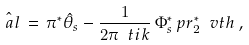<formula> <loc_0><loc_0><loc_500><loc_500>\hat { \ a l } \, = \, \pi ^ { * } \hat { \theta } _ { s } - \frac { 1 } { 2 \pi \ t i k } \, \Phi ^ { * } _ { s } \, p r _ { 2 } ^ { * } \ v t h \, ,</formula> 